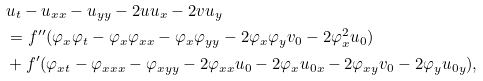Convert formula to latex. <formula><loc_0><loc_0><loc_500><loc_500>& u _ { t } - u _ { x x } - u _ { y y } - 2 u u _ { x } - 2 v u _ { y } \\ & = f ^ { \prime \prime } ( \varphi _ { x } \varphi _ { t } - \varphi _ { x } \varphi _ { x x } - \varphi _ { x } \varphi _ { y y } - 2 \varphi _ { x } \varphi _ { y } v _ { 0 } - 2 \varphi _ { x } ^ { 2 } u _ { 0 } ) \\ & + f ^ { \prime } ( \varphi _ { x t } - \varphi _ { x x x } - \varphi _ { x y y } - 2 \varphi _ { x x } u _ { 0 } - 2 \varphi _ { x } u _ { 0 x } - 2 \varphi _ { x y } v _ { 0 } - 2 \varphi _ { y } u _ { 0 y } ) ,</formula> 